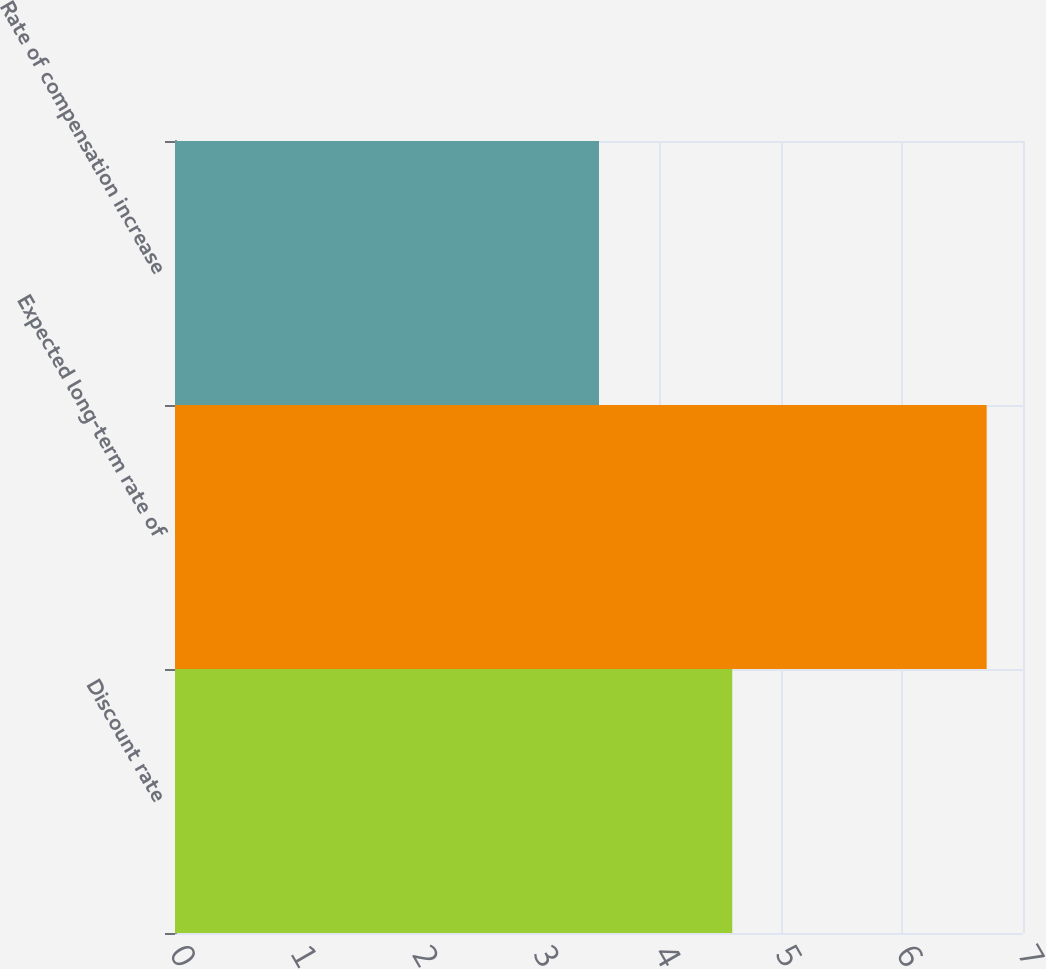Convert chart to OTSL. <chart><loc_0><loc_0><loc_500><loc_500><bar_chart><fcel>Discount rate<fcel>Expected long-term rate of<fcel>Rate of compensation increase<nl><fcel>4.6<fcel>6.7<fcel>3.5<nl></chart> 